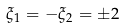Convert formula to latex. <formula><loc_0><loc_0><loc_500><loc_500>\xi _ { 1 } = - \xi _ { 2 } = \pm 2</formula> 